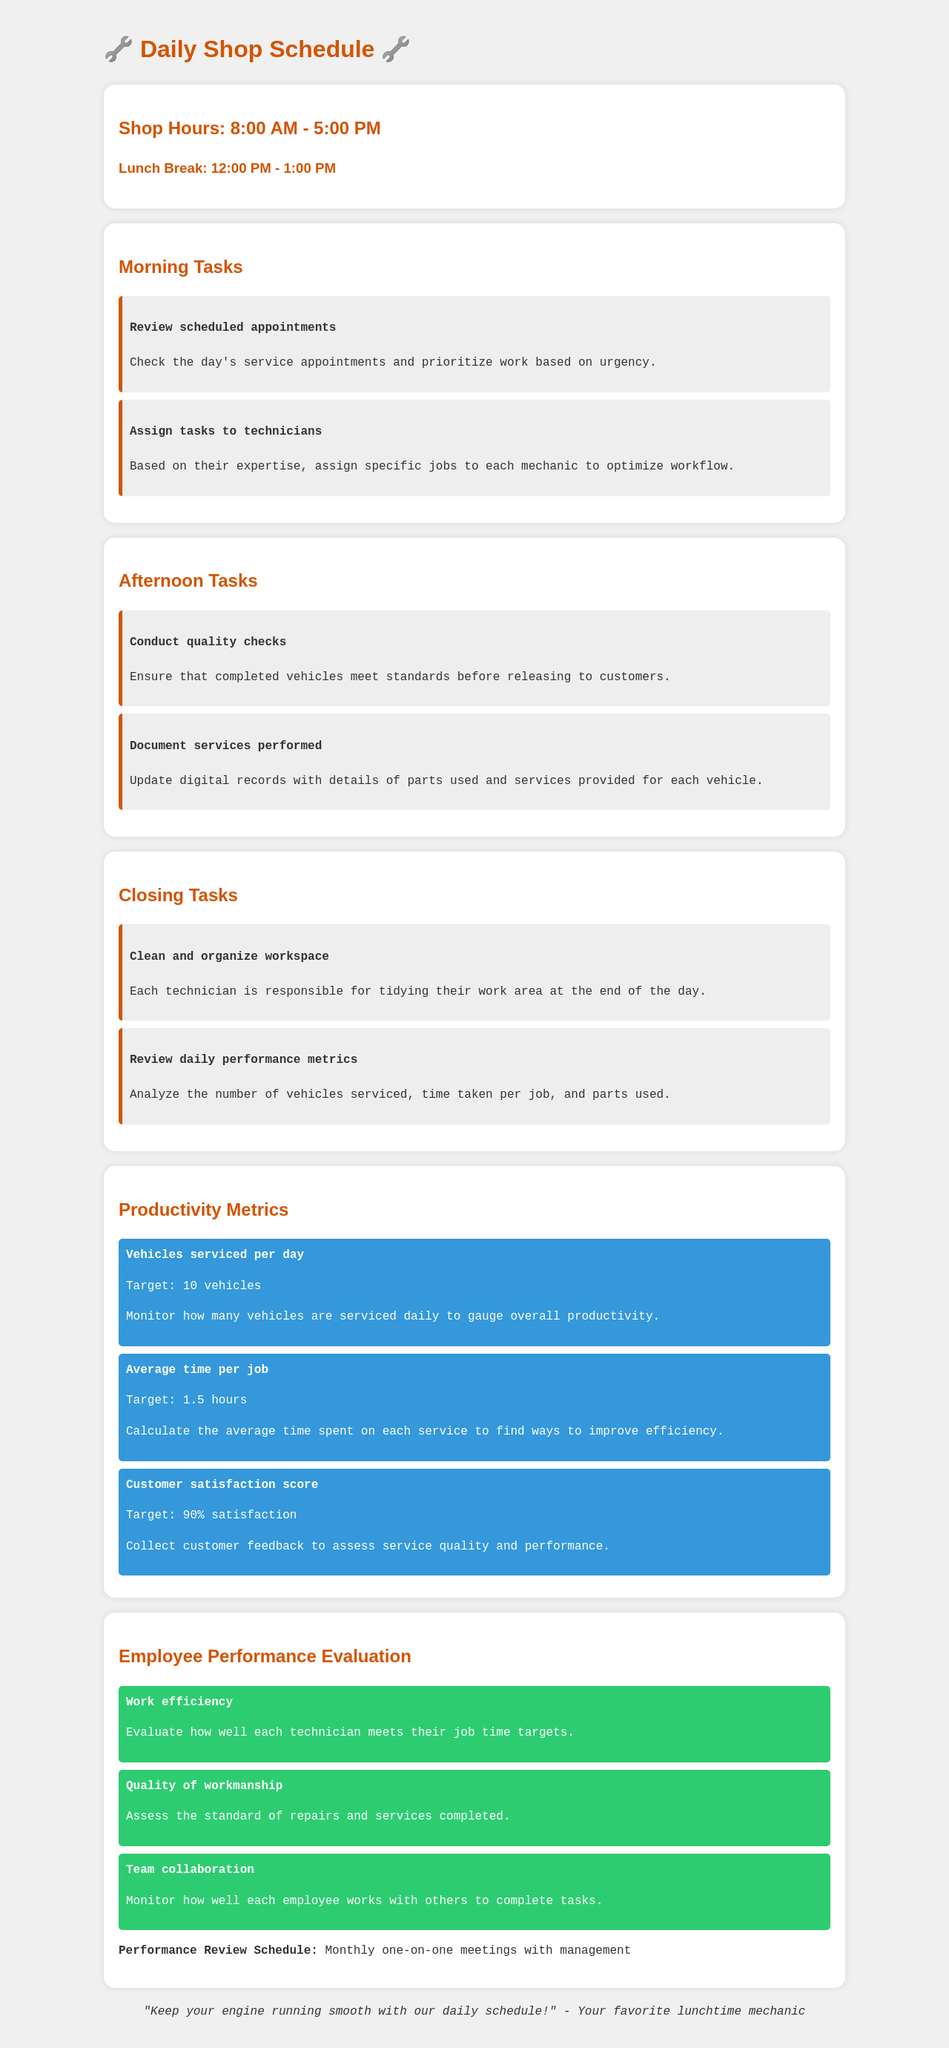What are the shop hours? The document specifies the shop hours from 8:00 AM to 5:00 PM.
Answer: 8:00 AM - 5:00 PM What is the target for vehicles serviced per day? The document indicates that the target for vehicles serviced daily is 10 vehicles.
Answer: 10 vehicles What is the lunch break duration? The schedule lists the lunch break from 12:00 PM to 1:00 PM.
Answer: 12:00 PM - 1:00 PM How often are performance reviews scheduled? The document mentions that performance review meetings occur monthly.
Answer: Monthly What is the average time target per job? According to the metrics section, the target for average time spent on each job is 1.5 hours.
Answer: 1.5 hours What task is assigned at the end of the day? The closing task listed involves cleaning and organizing the workspace.
Answer: Clean and organize workspace What metric assesses customer feedback? The document states that the customer satisfaction score gauges service quality and performance.
Answer: Customer satisfaction score What does the evaluation assess regarding teamwork? The evaluation section assesses how well each employee collaborates with others to complete tasks.
Answer: Team collaboration 